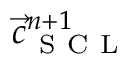Convert formula to latex. <formula><loc_0><loc_0><loc_500><loc_500>\vec { c } _ { S C L } ^ { n + 1 }</formula> 